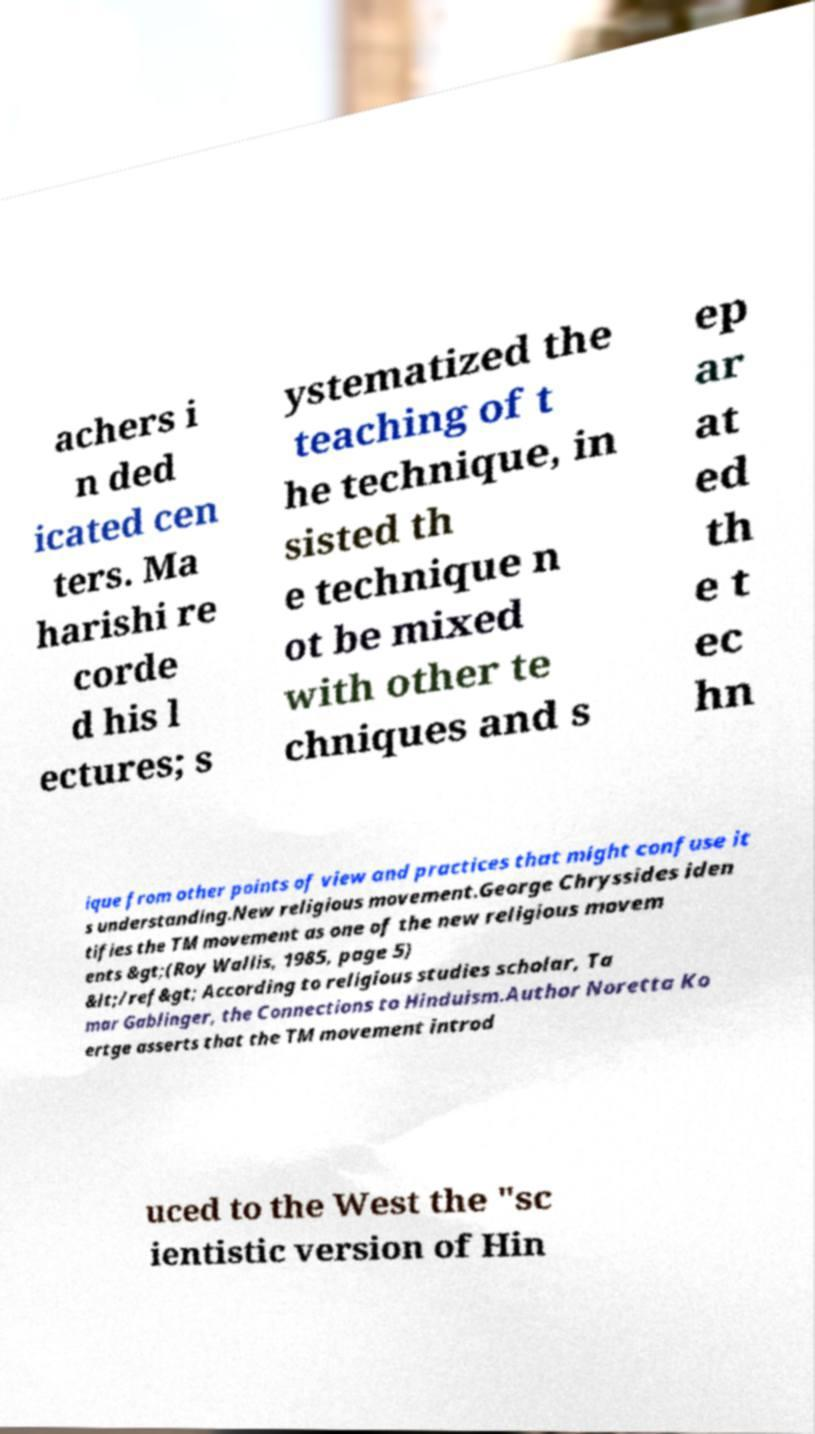I need the written content from this picture converted into text. Can you do that? achers i n ded icated cen ters. Ma harishi re corde d his l ectures; s ystematized the teaching of t he technique, in sisted th e technique n ot be mixed with other te chniques and s ep ar at ed th e t ec hn ique from other points of view and practices that might confuse it s understanding.New religious movement.George Chryssides iden tifies the TM movement as one of the new religious movem ents &gt;(Roy Wallis, 1985, page 5) &lt;/ref&gt; According to religious studies scholar, Ta mar Gablinger, the Connections to Hinduism.Author Noretta Ko ertge asserts that the TM movement introd uced to the West the "sc ientistic version of Hin 